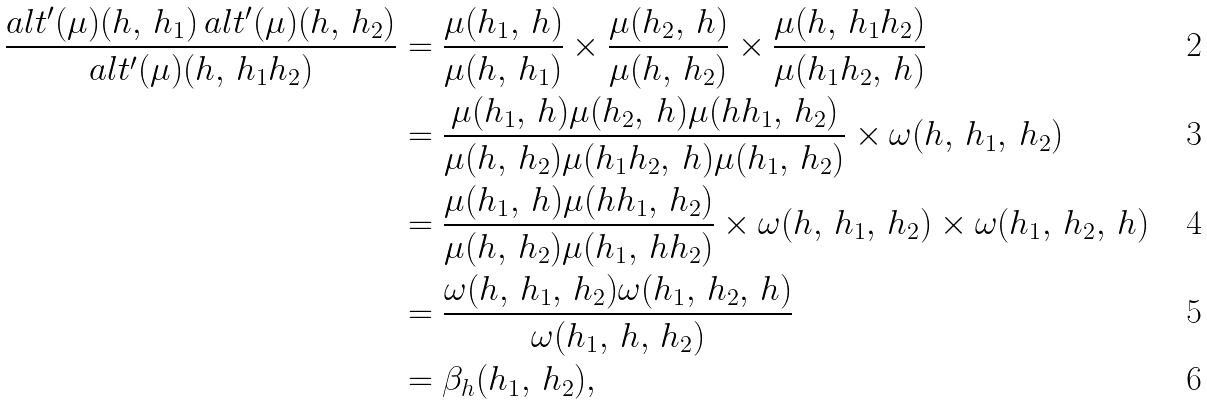<formula> <loc_0><loc_0><loc_500><loc_500>\frac { a l t ^ { \prime } ( \mu ) ( h , \, h _ { 1 } ) \, a l t ^ { \prime } ( \mu ) ( h , \, h _ { 2 } ) } { a l t ^ { \prime } ( \mu ) ( h , \, h _ { 1 } h _ { 2 } ) } & = \frac { \mu ( h _ { 1 } , \, h ) } { \mu ( h , \, h _ { 1 } ) } \times \frac { \mu ( h _ { 2 } , \, h ) } { \mu ( h , \, h _ { 2 } ) } \times \frac { \mu ( h , \, h _ { 1 } h _ { 2 } ) } { \mu ( h _ { 1 } h _ { 2 } , \, h ) } \\ & = \frac { \mu ( h _ { 1 } , \, h ) \mu ( h _ { 2 } , \, h ) \mu ( h h _ { 1 } , \, h _ { 2 } ) } { \mu ( h , \, h _ { 2 } ) \mu ( h _ { 1 } h _ { 2 } , \, h ) \mu ( h _ { 1 } , \, h _ { 2 } ) } \times \omega ( h , \, h _ { 1 } , \, h _ { 2 } ) \\ & = \frac { \mu ( h _ { 1 } , \, h ) \mu ( h h _ { 1 } , \, h _ { 2 } ) } { \mu ( h , \, h _ { 2 } ) \mu ( h _ { 1 } , \, h h _ { 2 } ) } \times \omega ( h , \, h _ { 1 } , \, h _ { 2 } ) \times \omega ( h _ { 1 } , \, h _ { 2 } , \, h ) \\ & = \frac { \omega ( h , \, h _ { 1 } , \, h _ { 2 } ) \omega ( h _ { 1 } , \, h _ { 2 } , \, h ) } { \omega ( h _ { 1 } , \, h , \, h _ { 2 } ) } \\ & = \beta _ { h } ( h _ { 1 } , \, h _ { 2 } ) ,</formula> 